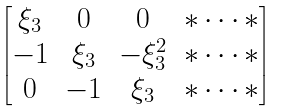Convert formula to latex. <formula><loc_0><loc_0><loc_500><loc_500>\begin{bmatrix} \xi _ { 3 } & 0 & 0 & * \dots * \\ - 1 & \xi _ { 3 } & - \xi _ { 3 } ^ { 2 } & * \dots * \\ 0 & - 1 & \xi _ { 3 } & * \dots * \end{bmatrix}</formula> 